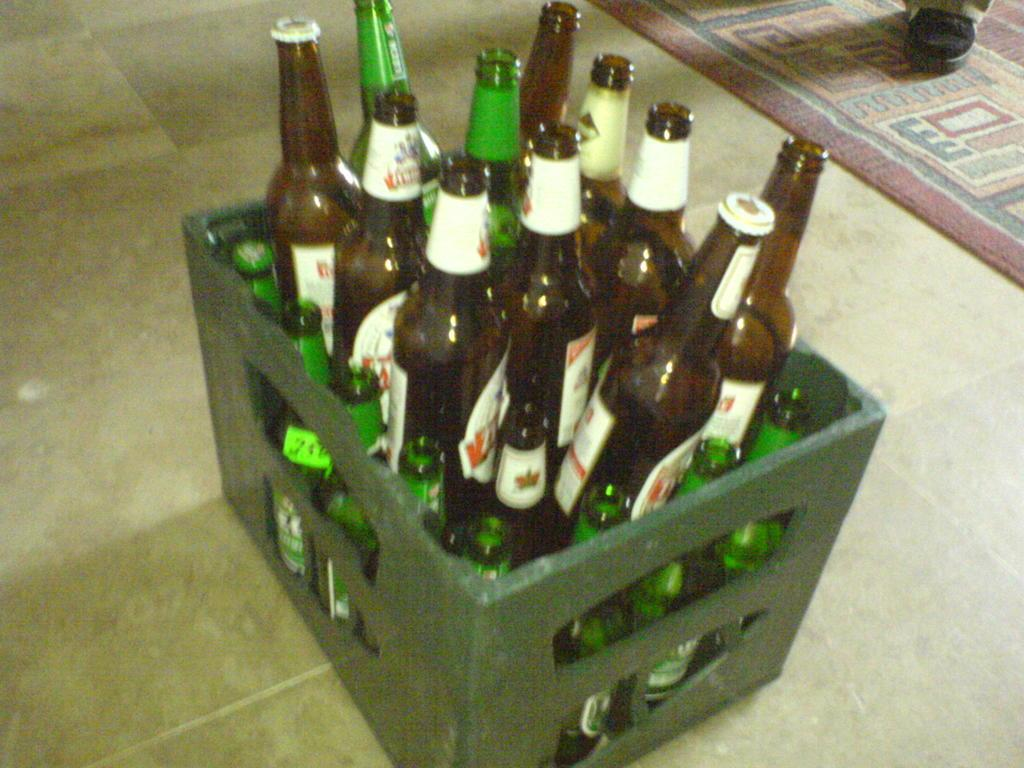What objects are visible in the image? There are bottles in the image. Where are the bottles placed? The bottles are on a box. What is the position of the box in the image? The box is on the floor. What can be seen on the right side of the image? There is a carpet on the right side of the image. What is placed on the carpet? There is a boot on the carpet. How many horses are pulling the truck in the image? There is no truck or horses present in the image. What advice does the uncle give about the boot in the image? There is no uncle present in the image, and therefore no advice can be given about the boot. 